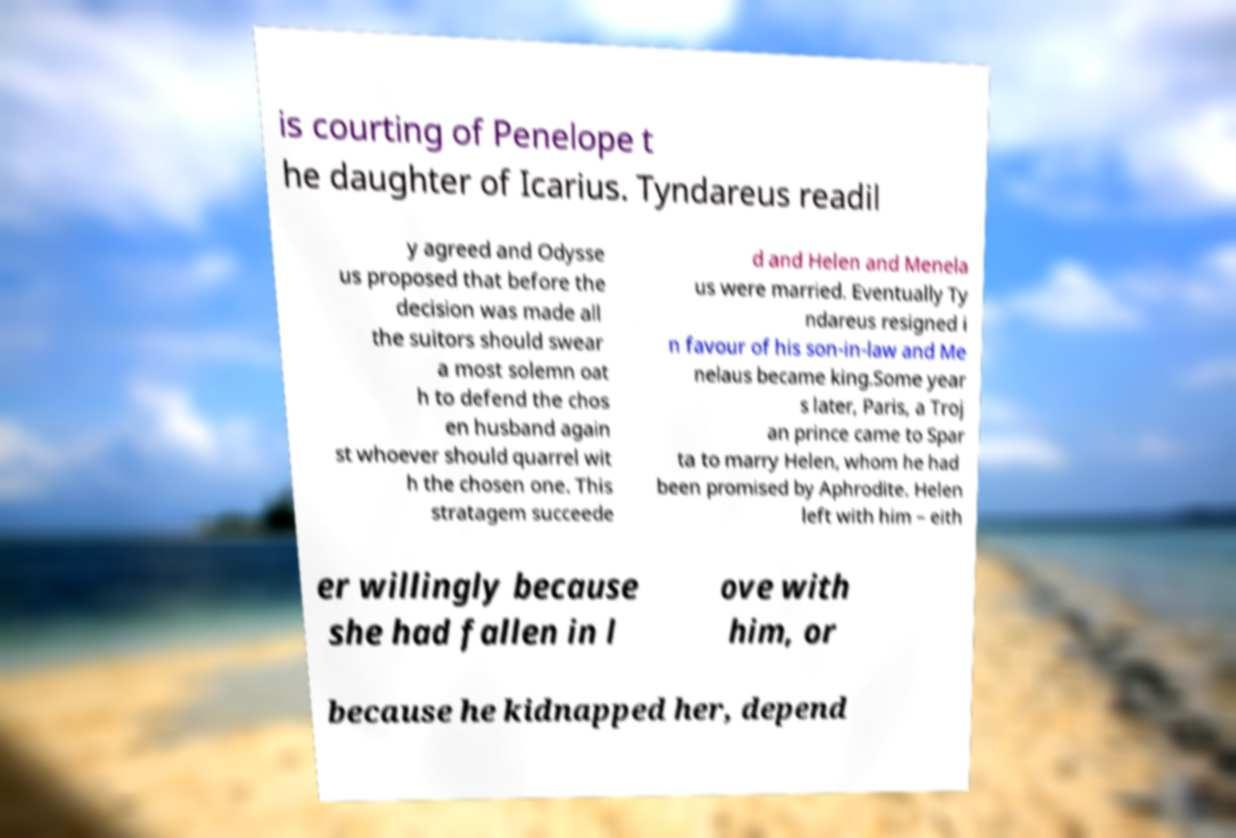Please read and relay the text visible in this image. What does it say? is courting of Penelope t he daughter of Icarius. Tyndareus readil y agreed and Odysse us proposed that before the decision was made all the suitors should swear a most solemn oat h to defend the chos en husband again st whoever should quarrel wit h the chosen one. This stratagem succeede d and Helen and Menela us were married. Eventually Ty ndareus resigned i n favour of his son-in-law and Me nelaus became king.Some year s later, Paris, a Troj an prince came to Spar ta to marry Helen, whom he had been promised by Aphrodite. Helen left with him – eith er willingly because she had fallen in l ove with him, or because he kidnapped her, depend 